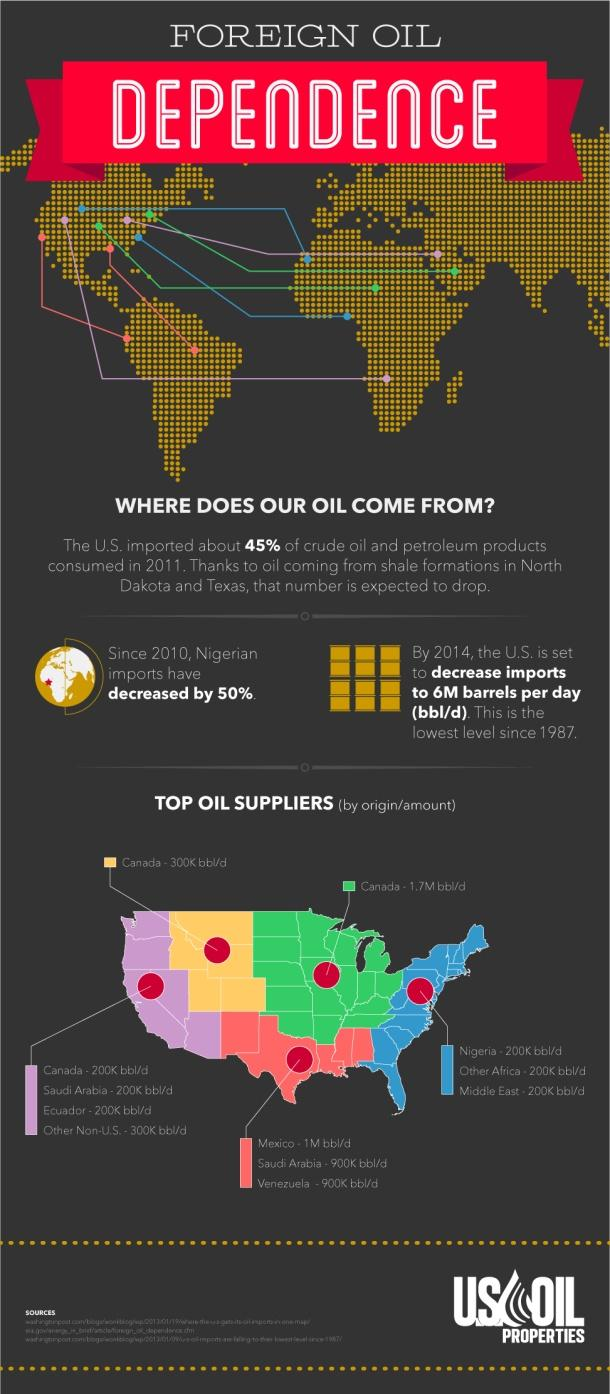Specify some key components in this picture. The third-largest oil supplier is assigned the color yellow. The state that is the biggest oil supplier is assigned the color green in its color code. 